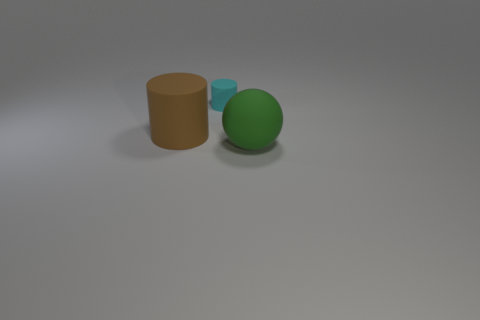Add 1 tiny gray metal things. How many objects exist? 4 Subtract all cylinders. How many objects are left? 1 Subtract 0 purple cylinders. How many objects are left? 3 Subtract all gray rubber cubes. Subtract all large brown cylinders. How many objects are left? 2 Add 3 cyan rubber cylinders. How many cyan rubber cylinders are left? 4 Add 2 green spheres. How many green spheres exist? 3 